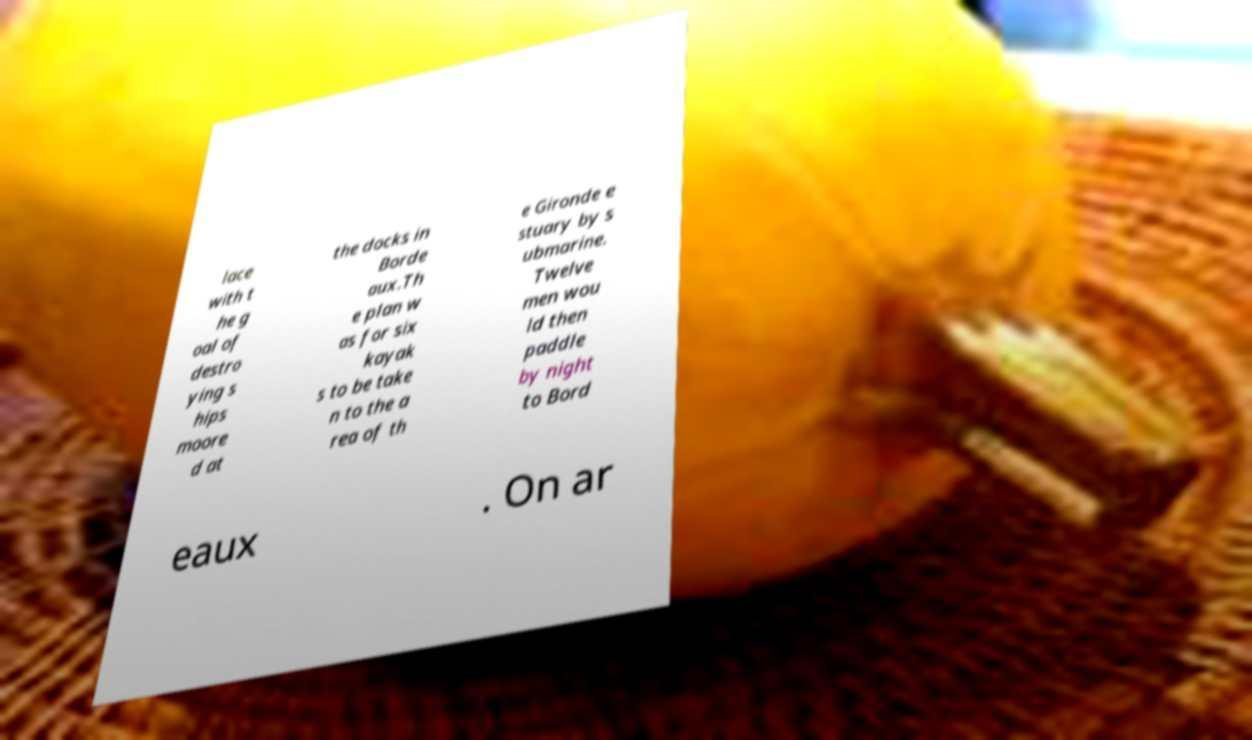What messages or text are displayed in this image? I need them in a readable, typed format. lace with t he g oal of destro ying s hips moore d at the docks in Borde aux.Th e plan w as for six kayak s to be take n to the a rea of th e Gironde e stuary by s ubmarine. Twelve men wou ld then paddle by night to Bord eaux . On ar 